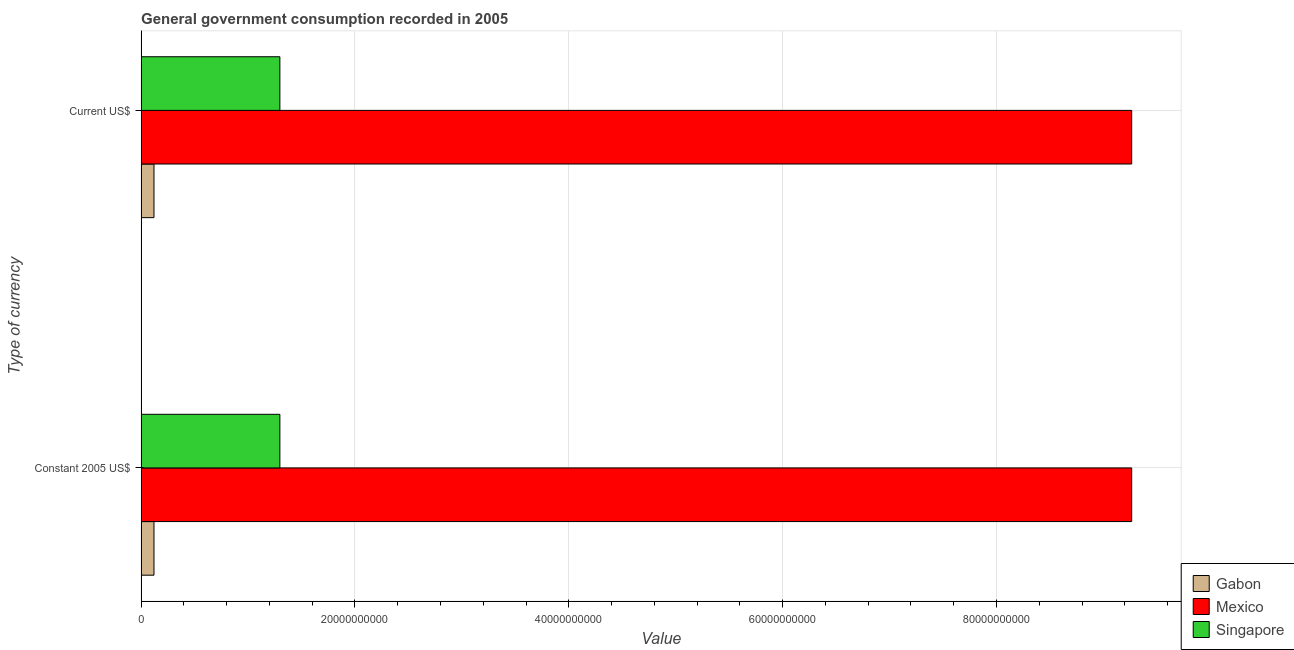How many different coloured bars are there?
Provide a short and direct response. 3. How many groups of bars are there?
Your answer should be very brief. 2. Are the number of bars on each tick of the Y-axis equal?
Provide a short and direct response. Yes. How many bars are there on the 1st tick from the top?
Offer a terse response. 3. How many bars are there on the 2nd tick from the bottom?
Make the answer very short. 3. What is the label of the 1st group of bars from the top?
Your answer should be compact. Current US$. What is the value consumed in current us$ in Singapore?
Provide a succinct answer. 1.30e+1. Across all countries, what is the maximum value consumed in current us$?
Keep it short and to the point. 9.26e+1. Across all countries, what is the minimum value consumed in current us$?
Your answer should be very brief. 1.20e+09. In which country was the value consumed in current us$ minimum?
Your answer should be compact. Gabon. What is the total value consumed in constant 2005 us$ in the graph?
Make the answer very short. 1.07e+11. What is the difference between the value consumed in current us$ in Singapore and that in Mexico?
Your answer should be very brief. -7.97e+1. What is the difference between the value consumed in current us$ in Gabon and the value consumed in constant 2005 us$ in Mexico?
Give a very brief answer. -9.14e+1. What is the average value consumed in current us$ per country?
Offer a terse response. 3.56e+1. What is the ratio of the value consumed in constant 2005 us$ in Singapore to that in Gabon?
Your answer should be very brief. 10.81. What does the 1st bar from the top in Constant 2005 US$ represents?
Offer a very short reply. Singapore. What does the 3rd bar from the bottom in Current US$ represents?
Provide a short and direct response. Singapore. How many countries are there in the graph?
Your answer should be very brief. 3. What is the difference between two consecutive major ticks on the X-axis?
Ensure brevity in your answer.  2.00e+1. Does the graph contain grids?
Your answer should be very brief. Yes. How many legend labels are there?
Offer a terse response. 3. How are the legend labels stacked?
Your answer should be compact. Vertical. What is the title of the graph?
Provide a succinct answer. General government consumption recorded in 2005. What is the label or title of the X-axis?
Your answer should be very brief. Value. What is the label or title of the Y-axis?
Offer a terse response. Type of currency. What is the Value of Gabon in Constant 2005 US$?
Make the answer very short. 1.20e+09. What is the Value in Mexico in Constant 2005 US$?
Your response must be concise. 9.26e+1. What is the Value in Singapore in Constant 2005 US$?
Keep it short and to the point. 1.30e+1. What is the Value of Gabon in Current US$?
Offer a very short reply. 1.20e+09. What is the Value in Mexico in Current US$?
Your answer should be compact. 9.26e+1. What is the Value in Singapore in Current US$?
Provide a succinct answer. 1.30e+1. Across all Type of currency, what is the maximum Value in Gabon?
Your answer should be very brief. 1.20e+09. Across all Type of currency, what is the maximum Value in Mexico?
Give a very brief answer. 9.26e+1. Across all Type of currency, what is the maximum Value in Singapore?
Provide a succinct answer. 1.30e+1. Across all Type of currency, what is the minimum Value in Gabon?
Offer a terse response. 1.20e+09. Across all Type of currency, what is the minimum Value in Mexico?
Provide a short and direct response. 9.26e+1. Across all Type of currency, what is the minimum Value of Singapore?
Make the answer very short. 1.30e+1. What is the total Value of Gabon in the graph?
Your answer should be very brief. 2.40e+09. What is the total Value of Mexico in the graph?
Your response must be concise. 1.85e+11. What is the total Value in Singapore in the graph?
Ensure brevity in your answer.  2.60e+1. What is the difference between the Value of Gabon in Constant 2005 US$ and that in Current US$?
Offer a terse response. 0. What is the difference between the Value in Mexico in Constant 2005 US$ and that in Current US$?
Provide a short and direct response. 0. What is the difference between the Value of Gabon in Constant 2005 US$ and the Value of Mexico in Current US$?
Make the answer very short. -9.14e+1. What is the difference between the Value in Gabon in Constant 2005 US$ and the Value in Singapore in Current US$?
Give a very brief answer. -1.18e+1. What is the difference between the Value in Mexico in Constant 2005 US$ and the Value in Singapore in Current US$?
Offer a terse response. 7.97e+1. What is the average Value in Gabon per Type of currency?
Offer a terse response. 1.20e+09. What is the average Value in Mexico per Type of currency?
Make the answer very short. 9.26e+1. What is the average Value of Singapore per Type of currency?
Provide a short and direct response. 1.30e+1. What is the difference between the Value in Gabon and Value in Mexico in Constant 2005 US$?
Your answer should be compact. -9.14e+1. What is the difference between the Value of Gabon and Value of Singapore in Constant 2005 US$?
Provide a succinct answer. -1.18e+1. What is the difference between the Value in Mexico and Value in Singapore in Constant 2005 US$?
Your answer should be very brief. 7.97e+1. What is the difference between the Value in Gabon and Value in Mexico in Current US$?
Offer a very short reply. -9.14e+1. What is the difference between the Value of Gabon and Value of Singapore in Current US$?
Provide a succinct answer. -1.18e+1. What is the difference between the Value in Mexico and Value in Singapore in Current US$?
Offer a very short reply. 7.97e+1. What is the ratio of the Value of Gabon in Constant 2005 US$ to that in Current US$?
Your response must be concise. 1. What is the difference between the highest and the second highest Value in Mexico?
Your answer should be very brief. 0. What is the difference between the highest and the second highest Value of Singapore?
Provide a succinct answer. 0. 